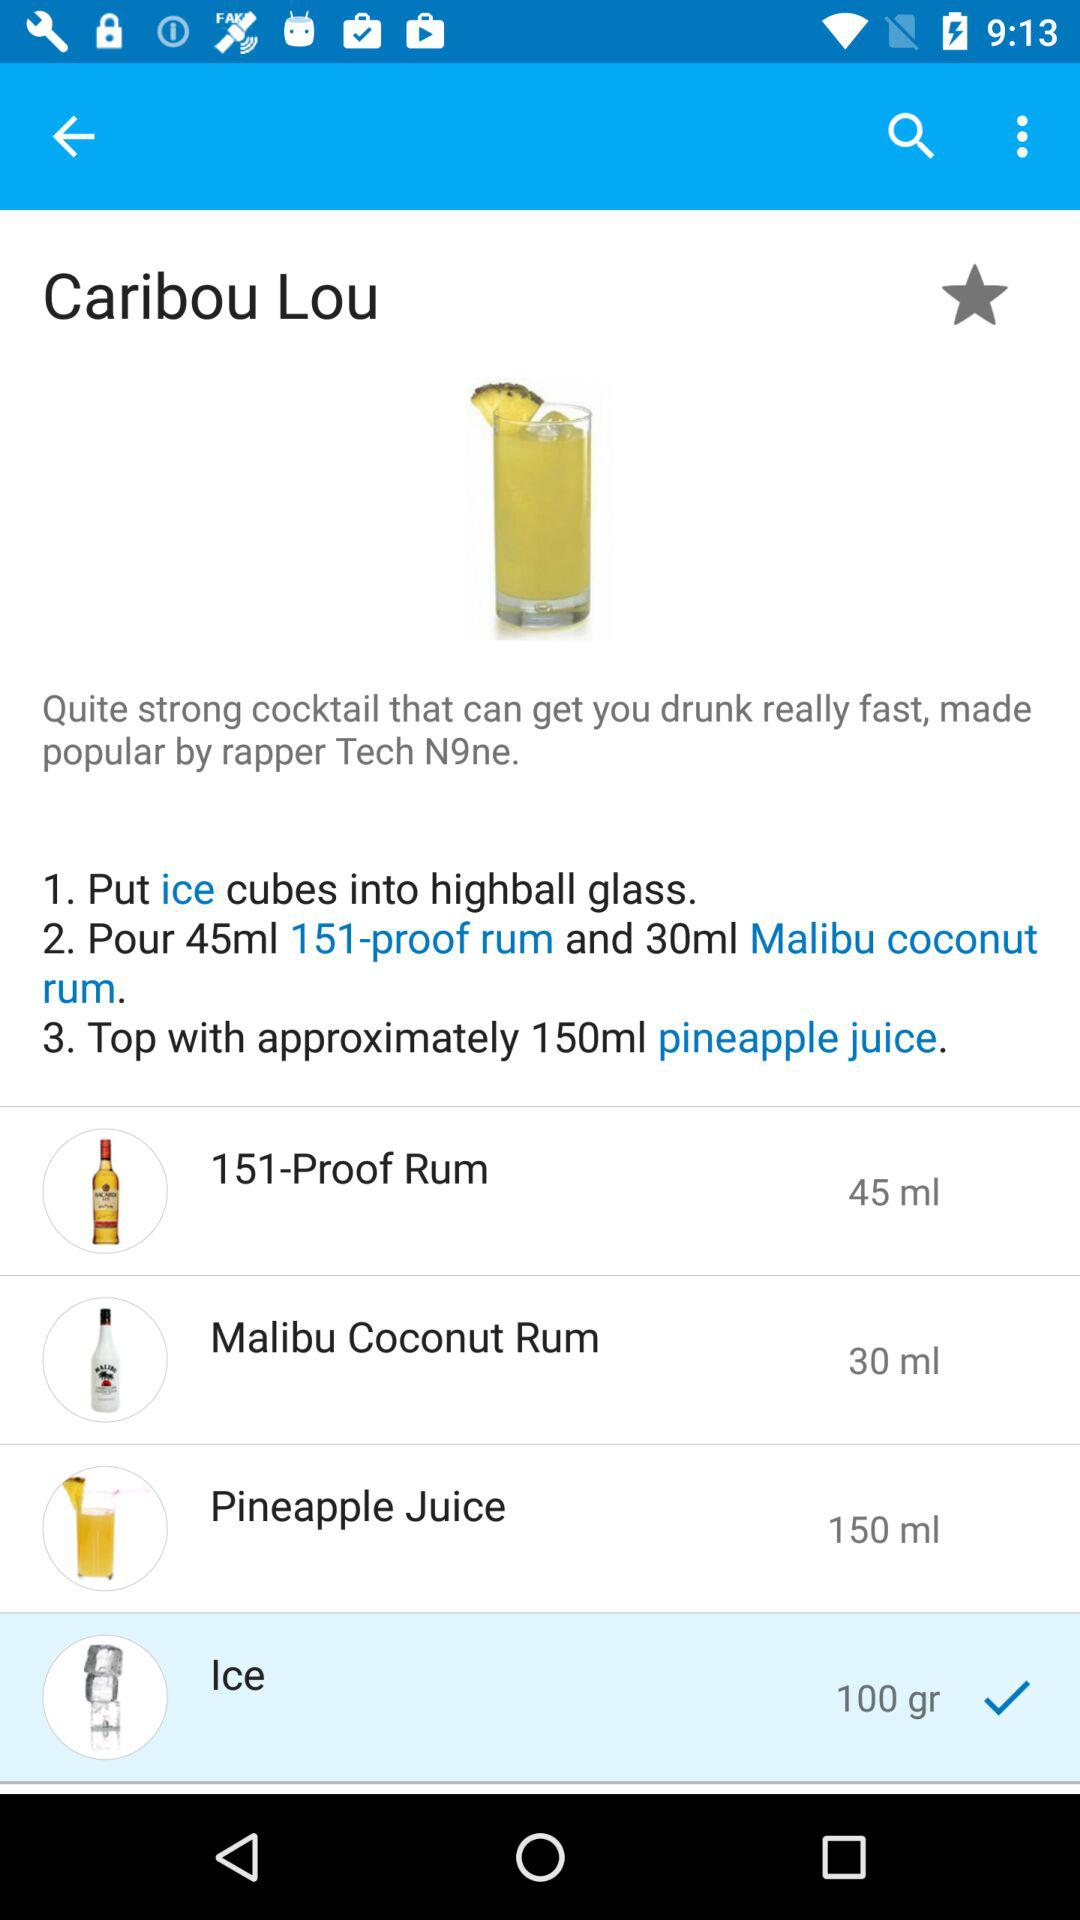What is the name of the product with a quantity of 45 ml? The name of the product is "151-Proof Rum". 